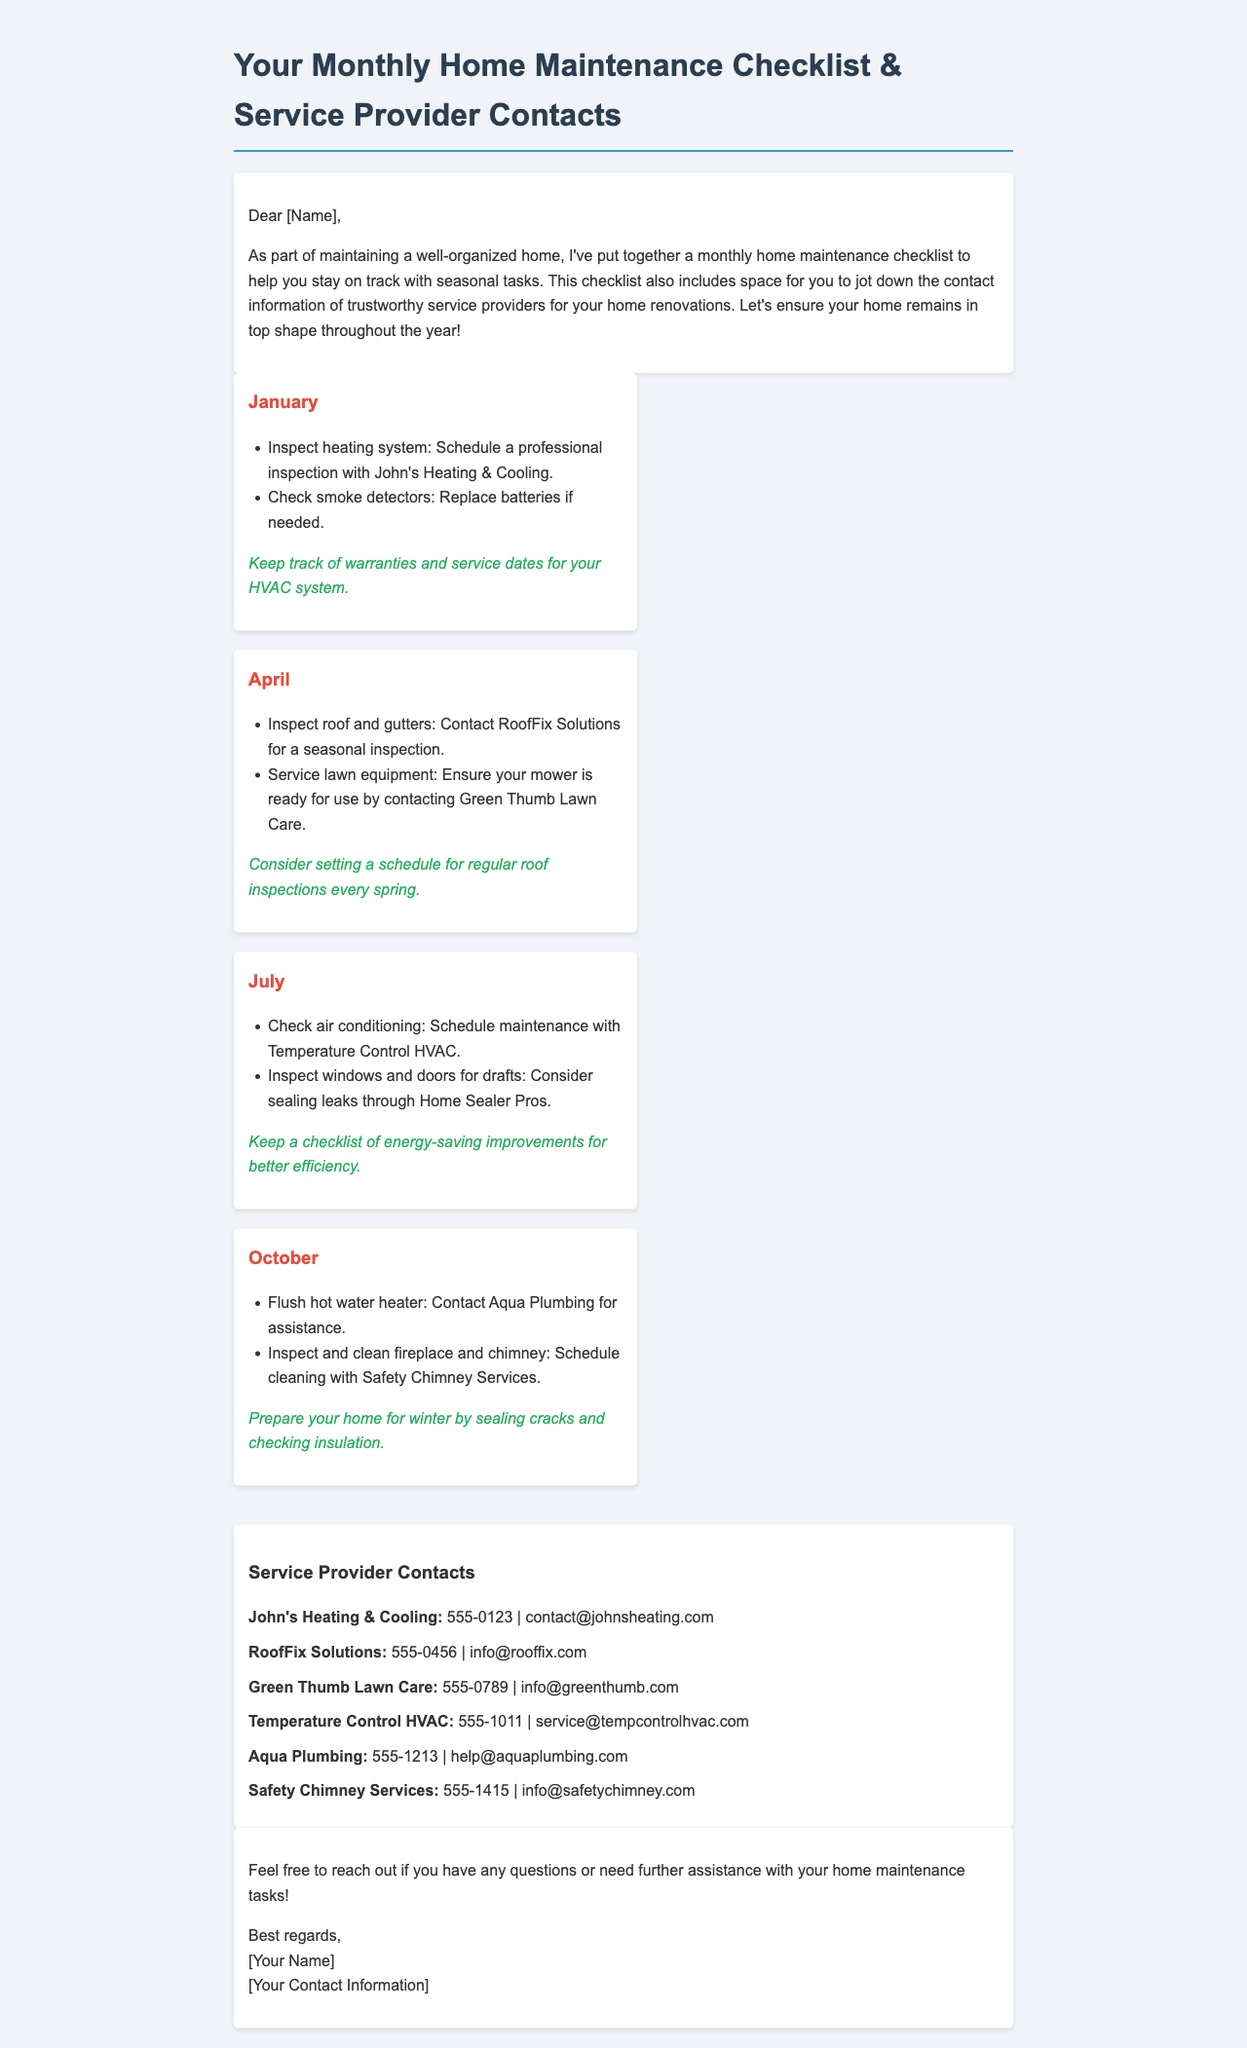What month is it recommended to inspect heating systems? The document states that heating system inspections should occur in January.
Answer: January Which service provider is listed for lawn equipment servicing? Green Thumb Lawn Care is mentioned for servicing lawn equipment in April.
Answer: Green Thumb Lawn Care How many service providers are listed in the document? There are six service providers listed for various tasks related to home maintenance.
Answer: 6 What is the contact number for Aqua Plumbing? The document provides the contact number for Aqua Plumbing as 555-1213.
Answer: 555-1213 In what month should the fireplace and chimney be inspected and cleaned? The document indicates that inspections and cleaning of the fireplace and chimney should be done in October.
Answer: October What is a tip mentioned for maintaining HVAC systems? The document advises to keep track of warranties and service dates for your HVAC system.
Answer: Keep track of warranties and service dates Which month includes a recommendation to check windows and doors for drafts? The maintenance checklist suggests checking windows and doors for drafts in July.
Answer: July Who should be contacted for roof inspections? RoofFix Solutions is recommended for roof inspections in April.
Answer: RoofFix Solutions What are the closing remarks of the document? The closing remarks indicate that the recipient should feel free to reach out for questions or further assistance.
Answer: Feel free to reach out for questions or further assistance 